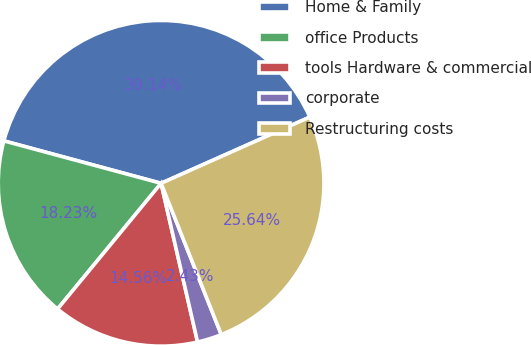<chart> <loc_0><loc_0><loc_500><loc_500><pie_chart><fcel>Home & Family<fcel>office Products<fcel>tools Hardware & commercial<fcel>corporate<fcel>Restructuring costs<nl><fcel>39.14%<fcel>18.23%<fcel>14.56%<fcel>2.43%<fcel>25.64%<nl></chart> 